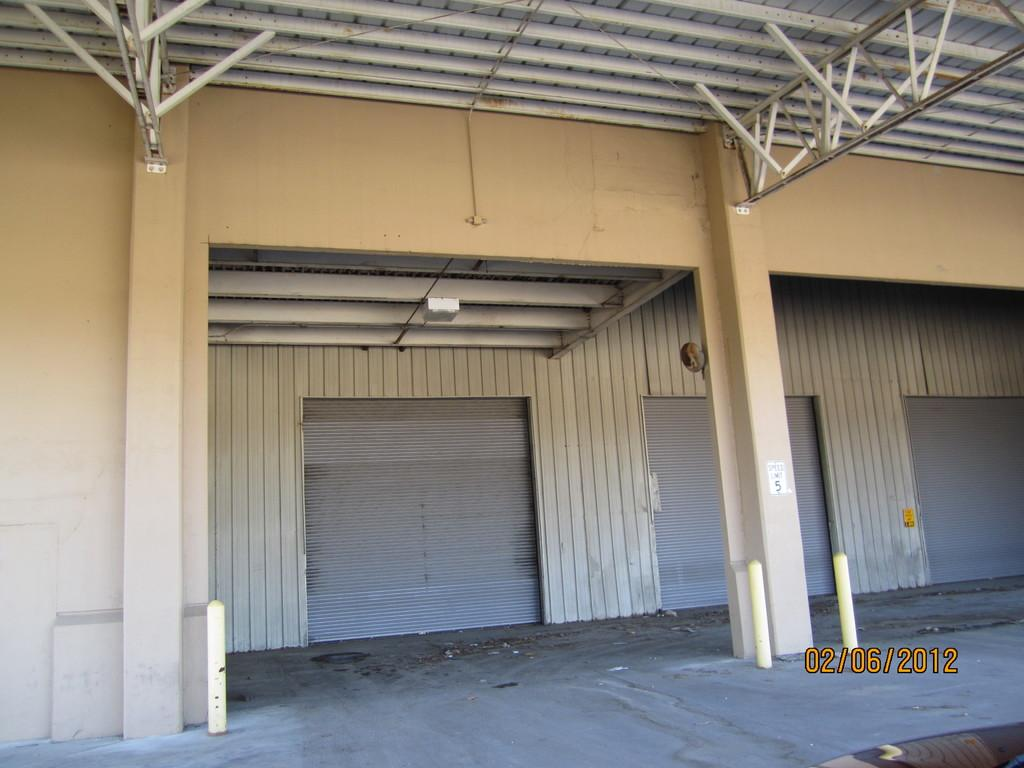What architectural features can be seen in the image? There are pillars and a wall visible in the image. What is located at the top of the image? There are rods visible at the top of the image. Where can the date be found in the image? The date is present in the bottom right side of the image. What brand of toothpaste is advertised on the wall in the image? There is no toothpaste or advertisement present in the image. What type of record can be seen on the pillars in the image? There are no records or any indication of records on the pillars in the image. 